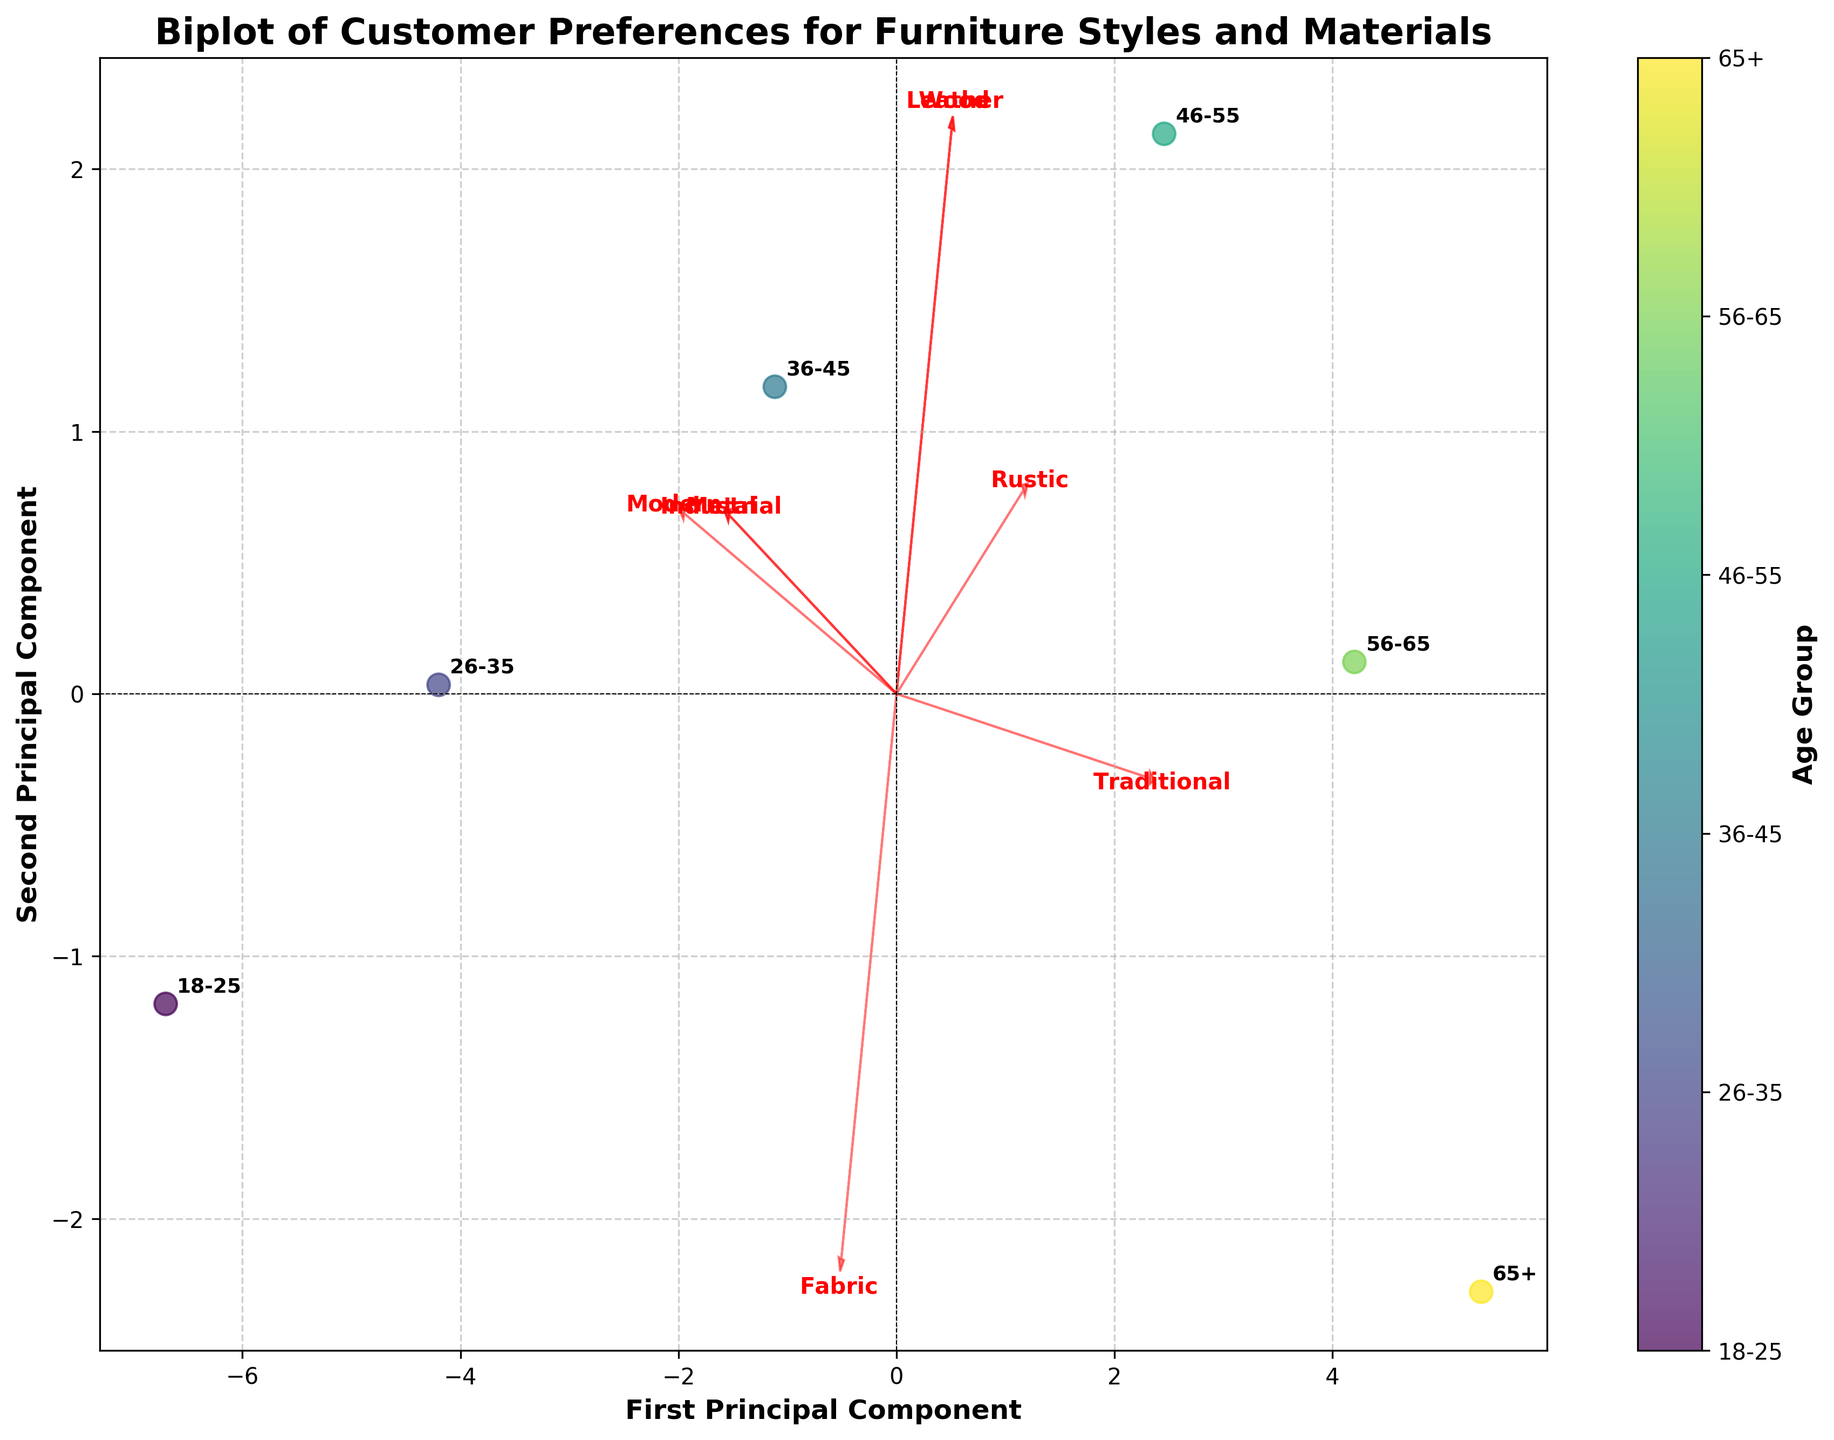What's the main title of the plot? The title of the plot is generally located at the top of the figure and it is meant to summarize the content or purpose of the plot.
Answer: Biplot of Customer Preferences for Furniture Styles and Materials What do the x-axis and y-axis represent? The x-axis and y-axis are labeled with descriptions of what each principal component represents. They often include terms like "Principal Component" along with numbering.
Answer: First Principal Component and Second Principal Component Which age group is associated with the highest preference for traditional style? By looking at the annotated age group labels and the vector for traditional style on the biplot, the group positioned furthest in the direction of the Traditional vector will have the highest preference.
Answer: 65+ How does the preference for metal materials compare between the 18-25 age group and the 56-65 age group? Identify the positions of the 18-25 and 56-65 age groups on the biplot, and compare how closely they're aligned with the Metal vector.
Answer: 18-25 has higher preference for metal than 56-65 Which feature vector has the least magnitude and what does this imply about the data? The magnitude of a feature vector on a biplot is represented by its length. The shortest arrow indicates the feature vector with the least variance among the data points.
Answer: Fabric; implies least variability in preferences for fabric across age groups Are the preferences for rustic and industrial styles positively correlated? Check the direction of the vectors for rustic and industrial styles. If they point in similar directions or have a small angle between them, it suggests a positive correlation.
Answer: Yes Which two age groups have the most similar preferences based on this biplot? By examining the proximity of age groups on the scatter plot part of the biplot, the closest pairs of points indicate the most similar preferences.
Answer: 26-35 and 36-45 In which age group does wood seem to be least preferred? Find the age group that is farthest from the Wood vector on the biplot.
Answer: 18-25 What do the components of the vectors represent in the context of this biplot? The vectors represent the direction in which each feature (e.g., traditional, modern) increases. The components are scaled to fit within the plotted space, showing the importance and variance of each feature in different directions.
Answer: Direction and variance of features across principal components 